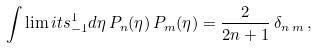Convert formula to latex. <formula><loc_0><loc_0><loc_500><loc_500>\int \lim i t s _ { - 1 } ^ { 1 } d \eta \, P _ { n } ( \eta ) \, P _ { m } ( \eta ) = \frac { 2 } { 2 n + 1 } \, \delta _ { n \, m } \, ,</formula> 